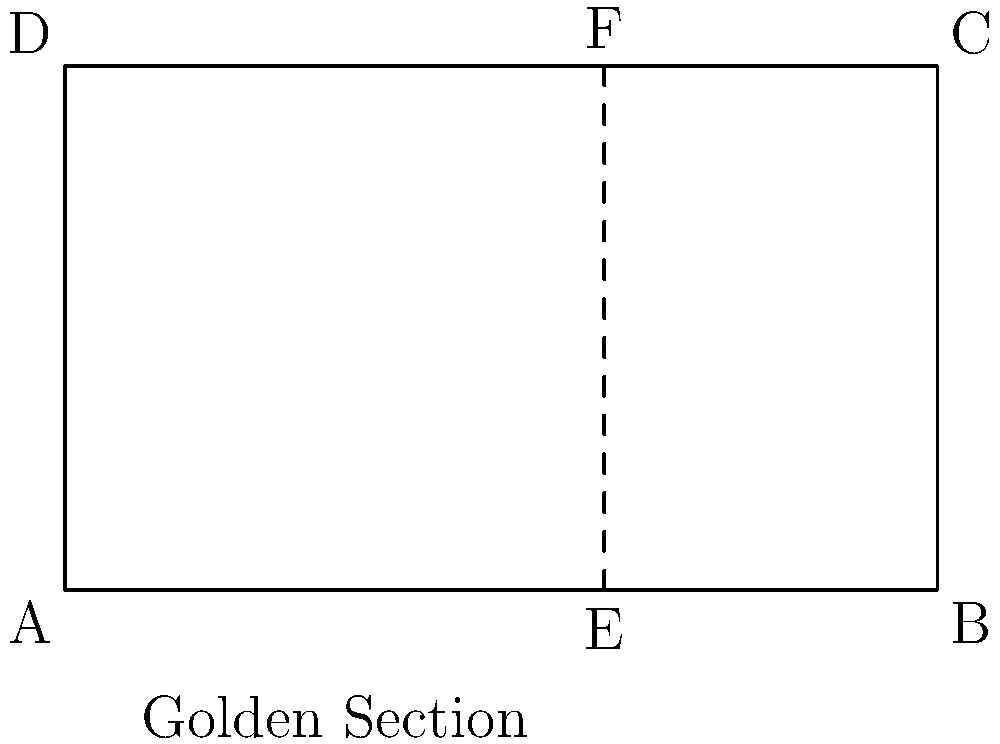In designing your latest album cover, you decide to incorporate the golden ratio for its aesthetic appeal. If the width of the album cover is 5 inches, at what distance from the left edge should you place a vertical line to divide the cover according to the golden ratio? Round your answer to two decimal places. To find the position of the vertical line that divides the album cover according to the golden ratio, we need to follow these steps:

1. Recall that the golden ratio is approximately 1.618034...

2. The golden ratio is often expressed as a division of a line segment where:
   $\frac{\text{longer part}}{\text{shorter part}} = \frac{\text{whole}}{\text{longer part}} \approx 1.618$

3. Let x be the length of the shorter segment. Then:
   $\frac{5-x}{x} = \frac{5}{5-x} \approx 1.618$

4. We can simplify this to:
   $\frac{5}{5-x} \approx 1.618$

5. Solving for x:
   $5 \approx 1.618(5-x)$
   $5 \approx 8.09 - 1.618x$
   $1.618x \approx 3.09$
   $x \approx 1.91$

6. Therefore, the longer segment is approximately 5 - 1.91 = 3.09 inches

7. To verify:
   $\frac{3.09}{1.91} \approx 1.618$

8. Rounding to two decimal places, the vertical line should be placed 3.09 inches from the left edge, or equivalently, 1.91 inches from the right edge.
Answer: 3.09 inches 